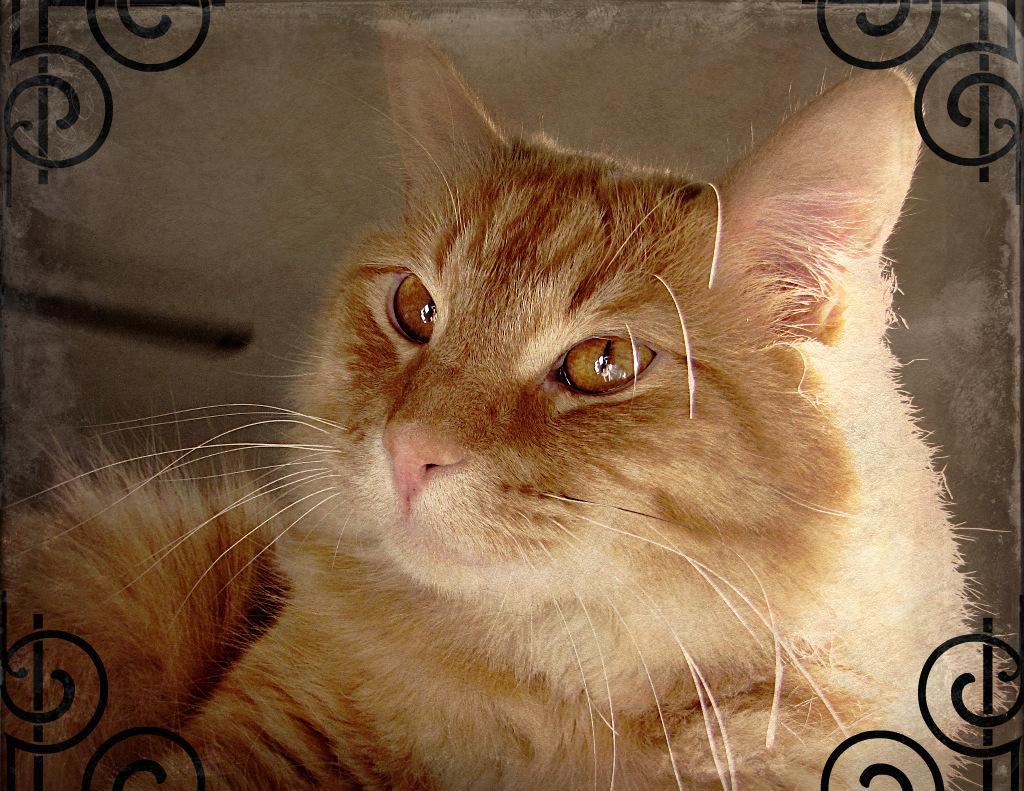How would you summarize this image in a sentence or two? There is a brown color cat sitting on an object. In front of it, there are designs on the four corners. In the background, there is wall. 